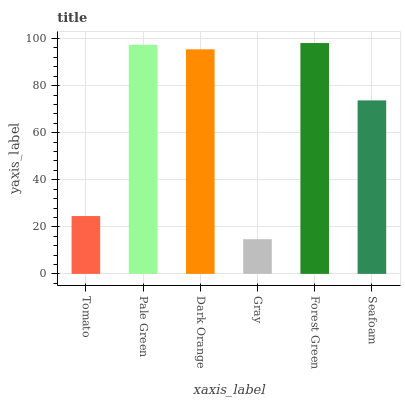Is Gray the minimum?
Answer yes or no. Yes. Is Forest Green the maximum?
Answer yes or no. Yes. Is Pale Green the minimum?
Answer yes or no. No. Is Pale Green the maximum?
Answer yes or no. No. Is Pale Green greater than Tomato?
Answer yes or no. Yes. Is Tomato less than Pale Green?
Answer yes or no. Yes. Is Tomato greater than Pale Green?
Answer yes or no. No. Is Pale Green less than Tomato?
Answer yes or no. No. Is Dark Orange the high median?
Answer yes or no. Yes. Is Seafoam the low median?
Answer yes or no. Yes. Is Forest Green the high median?
Answer yes or no. No. Is Dark Orange the low median?
Answer yes or no. No. 